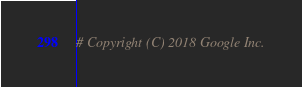<code> <loc_0><loc_0><loc_500><loc_500><_Python_># Copyright (C) 2018 Google Inc.</code> 